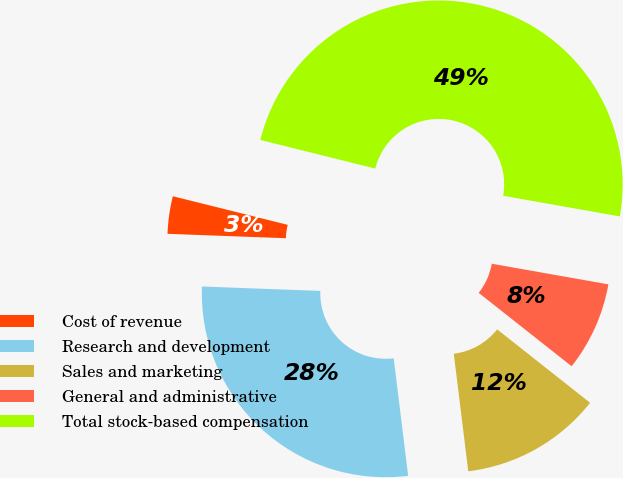Convert chart. <chart><loc_0><loc_0><loc_500><loc_500><pie_chart><fcel>Cost of revenue<fcel>Research and development<fcel>Sales and marketing<fcel>General and administrative<fcel>Total stock-based compensation<nl><fcel>3.29%<fcel>27.54%<fcel>12.41%<fcel>7.85%<fcel>48.9%<nl></chart> 